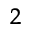Convert formula to latex. <formula><loc_0><loc_0><loc_500><loc_500>^ { 2 }</formula> 